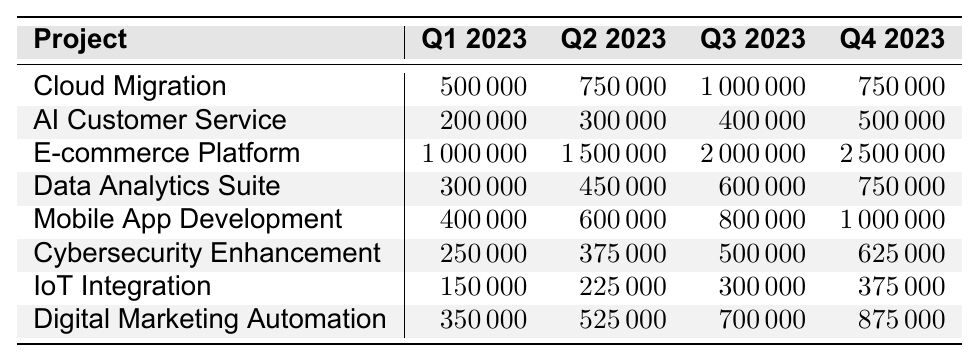What is the budget for the E-commerce Platform in Q2 2023? The E-commerce Platform has a budget of 1,500,000 in Q2 2023, as seen in the corresponding cell of the table.
Answer: 1,500,000 Which project has the highest budget in Q4 2023? In Q4 2023, the E-commerce Platform has the highest budget of 2,500,000, as it is the largest value in that column.
Answer: E-commerce Platform What is the total budget allocated for Cloud Migration across all quarters? Adding the budgets for Cloud Migration: 500,000 + 750,000 + 1,000,000 + 750,000 equals 3,000,000.
Answer: 3,000,000 Is the budget for Mobile App Development in Q1 2023 higher than the budget for IoT Integration in the same quarter? The budget for Mobile App Development in Q1 2023 is 400,000, while IoT Integration has a budget of 150,000. Since 400,000 is greater than 150,000, the statement is true.
Answer: Yes What is the average budget allocated for Cybersecurity Enhancement across all quarters? To find the average, sum the budgets: 250,000 + 375,000 + 500,000 + 625,000 equals 1,750,000. There are 4 quarters, so the average is 1,750,000 divided by 4, which equals 437,500.
Answer: 437,500 Which project saw the largest increase in budget from Q1 to Q4 2023? Calculating the change for each project: E-commerce Platform increases by 1,500,000 (from 1,000,000 to 2,500,000), Cloud Migration increases by 250,000, and the rest are smaller. The E-commerce Platform has the largest increase of 1,500,000.
Answer: E-commerce Platform What is the combined budget for AI Customer Service and Data Analytics Suite in Q3 2023? The budget for AI Customer Service in Q3 2023 is 400,000, and for Data Analytics Suite, it is 600,000. Combined, they total 400,000 + 600,000 equals 1,000,000.
Answer: 1,000,000 Was the budget for Digital Marketing Automation in Q4 2023 less than the budget for Cybersecurity Enhancement in the same quarter? The budget for Digital Marketing Automation in Q4 2023 is 875,000, while Cybersecurity Enhancement has a budget of 625,000. Since 875,000 is greater, the statement is false.
Answer: No How much more budget is allocated to the Mobile App Development project in Q3 compared to Q1? The budget for Mobile App Development in Q3 is 800,000 and in Q1 is 400,000. The difference is 800,000 - 400,000 which equals 400,000.
Answer: 400,000 What percentage of the total budget in Q2 2023 is allocated to the Cloud Migration project? First, sum the budgets for Q2 2023: 750,000 (Cloud Migration) + 300,000 + 1,500,000 + 450,000 + 600,000 + 375,000 + 225,000 + 525,000 = 4,375,000. The percentage for Cloud Migration is (750,000 / 4,375,000) * 100, which equals 17.14%.
Answer: 17.14% 